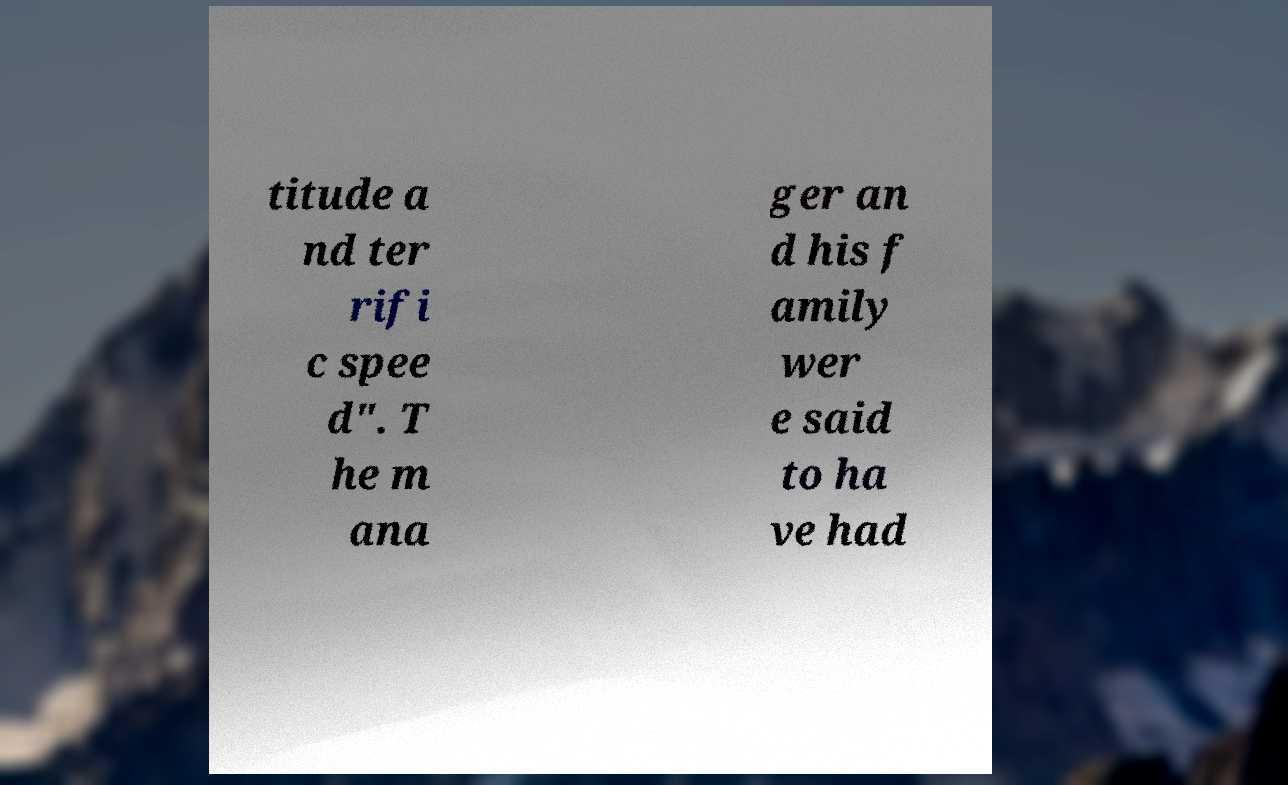Could you extract and type out the text from this image? titude a nd ter rifi c spee d". T he m ana ger an d his f amily wer e said to ha ve had 